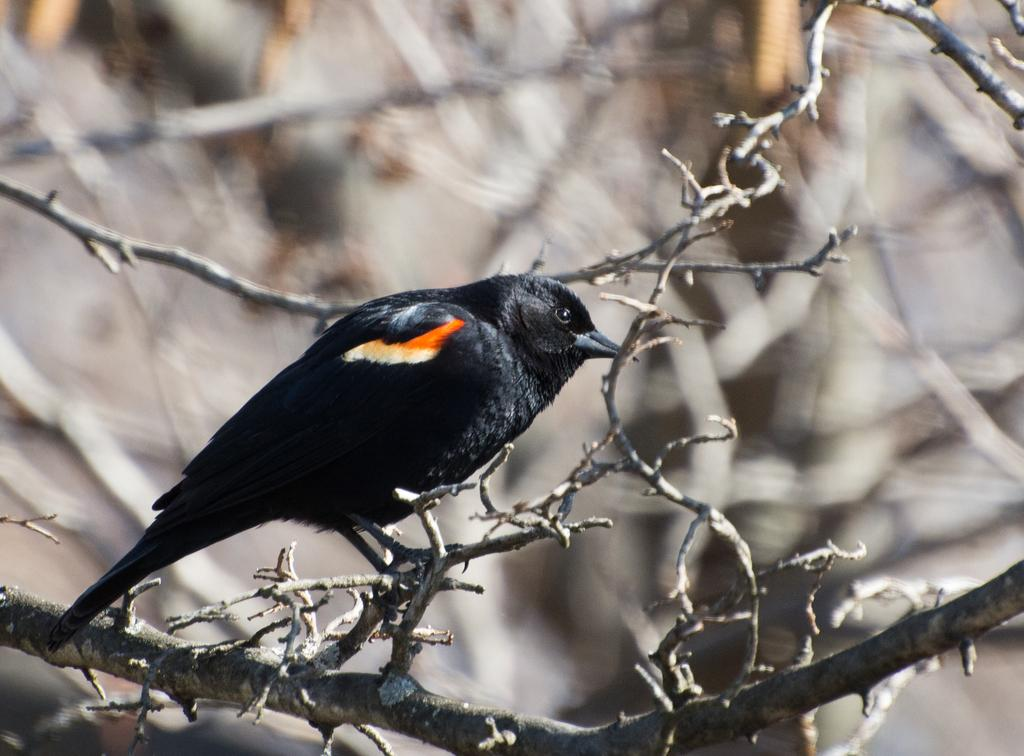What type of animal is in the image? There is a black bird in the image. Where is the bird located? The bird is standing on a branch. Can you describe the background of the image? The background of the image is blurred. What type of action is taking place in the market in the image? There is no market or action present in the image; it features a black bird standing on a branch with a blurred background. 